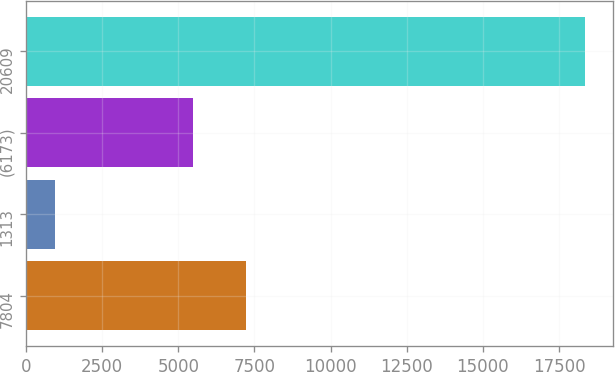Convert chart. <chart><loc_0><loc_0><loc_500><loc_500><bar_chart><fcel>7804<fcel>1313<fcel>(6173)<fcel>20609<nl><fcel>7232.4<fcel>944<fcel>5491<fcel>18358<nl></chart> 